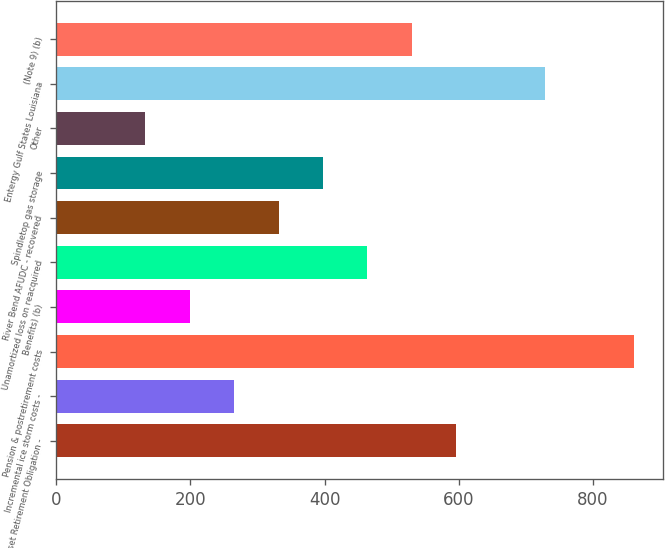Convert chart. <chart><loc_0><loc_0><loc_500><loc_500><bar_chart><fcel>Asset Retirement Obligation -<fcel>Incremental ice storm costs -<fcel>Pension & postretirement costs<fcel>Benefits) (b)<fcel>Unamortized loss on reacquired<fcel>River Bend AFUDC - recovered<fcel>Spindletop gas storage<fcel>Other<fcel>Entergy Gulf States Louisiana<fcel>(Note 9) (b)<nl><fcel>596.47<fcel>265.32<fcel>861.39<fcel>199.09<fcel>464.01<fcel>331.55<fcel>397.78<fcel>132.86<fcel>728.93<fcel>530.24<nl></chart> 